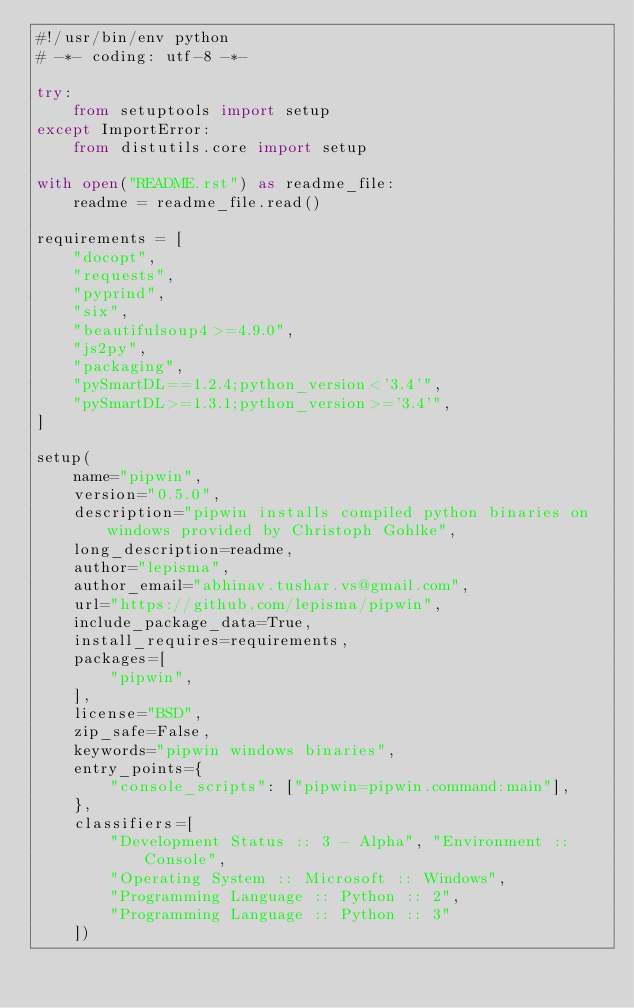Convert code to text. <code><loc_0><loc_0><loc_500><loc_500><_Python_>#!/usr/bin/env python
# -*- coding: utf-8 -*-

try:
    from setuptools import setup
except ImportError:
    from distutils.core import setup

with open("README.rst") as readme_file:
    readme = readme_file.read()

requirements = [
    "docopt",
    "requests",
    "pyprind",
    "six",
    "beautifulsoup4>=4.9.0",
    "js2py",
    "packaging",
    "pySmartDL==1.2.4;python_version<'3.4'",
    "pySmartDL>=1.3.1;python_version>='3.4'",
]

setup(
    name="pipwin",
    version="0.5.0",
    description="pipwin installs compiled python binaries on windows provided by Christoph Gohlke",
    long_description=readme,
    author="lepisma",
    author_email="abhinav.tushar.vs@gmail.com",
    url="https://github.com/lepisma/pipwin",
    include_package_data=True,
    install_requires=requirements,
    packages=[
        "pipwin",
    ],
    license="BSD",
    zip_safe=False,
    keywords="pipwin windows binaries",
    entry_points={
        "console_scripts": ["pipwin=pipwin.command:main"],
    },
    classifiers=[
        "Development Status :: 3 - Alpha", "Environment :: Console",
        "Operating System :: Microsoft :: Windows",
        "Programming Language :: Python :: 2",
        "Programming Language :: Python :: 3"
    ])
</code> 